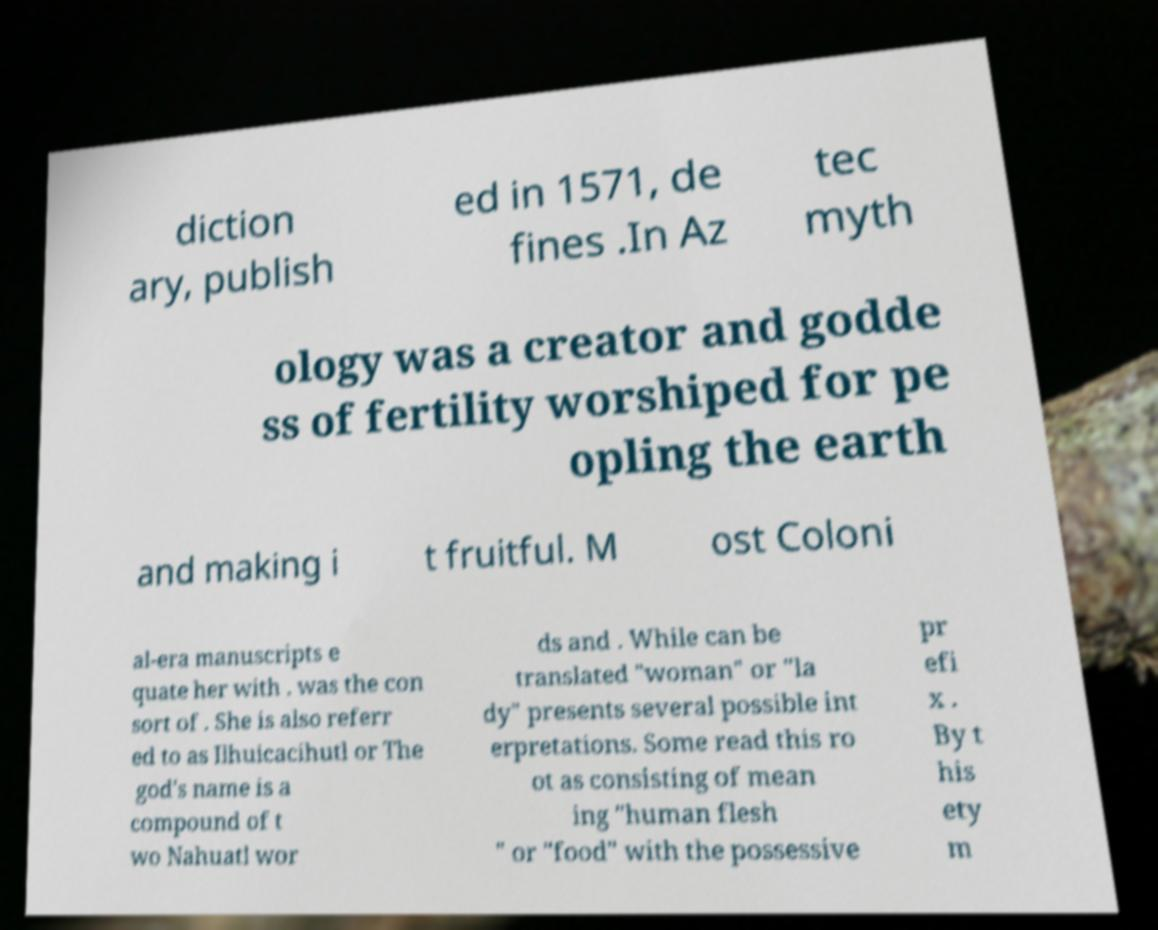There's text embedded in this image that I need extracted. Can you transcribe it verbatim? diction ary, publish ed in 1571, de fines .In Az tec myth ology was a creator and godde ss of fertility worshiped for pe opling the earth and making i t fruitful. M ost Coloni al-era manuscripts e quate her with . was the con sort of . She is also referr ed to as Ilhuicacihutl or The god's name is a compound of t wo Nahuatl wor ds and . While can be translated "woman" or "la dy" presents several possible int erpretations. Some read this ro ot as consisting of mean ing "human flesh " or "food" with the possessive pr efi x . By t his ety m 